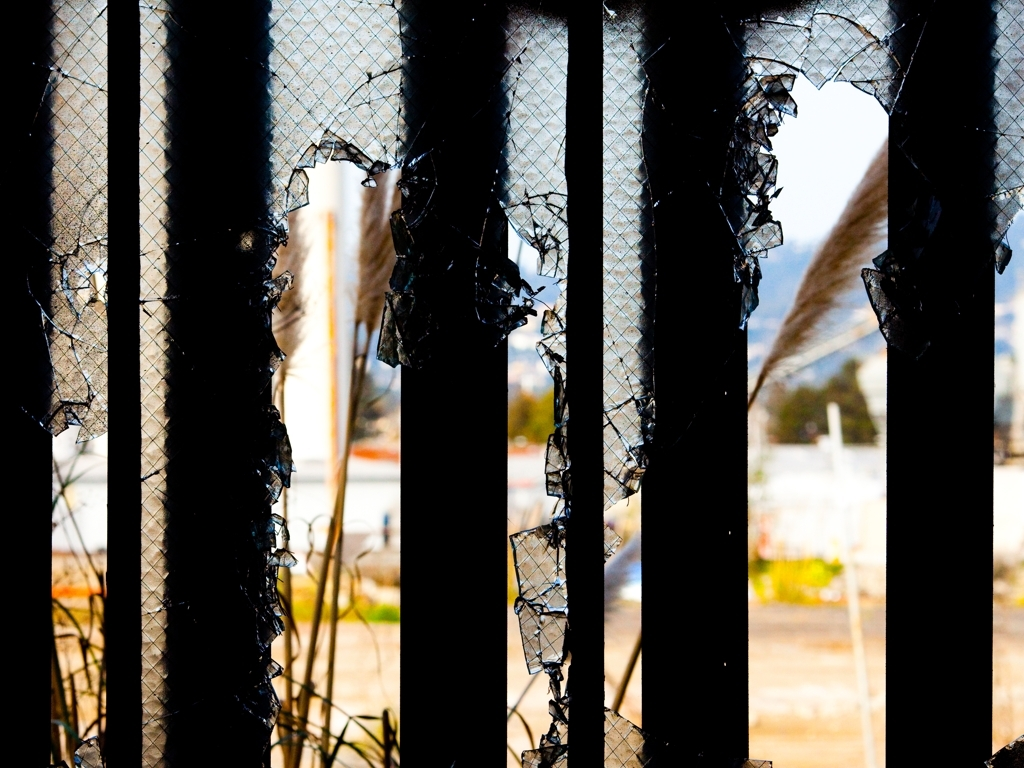Can you tell what the weather might be like in this photo? The lighting in the photo is bright and the shadows are well-defined, suggesting that the sun is shining and that the weather is clear. The absence of any rain or snow on the surfaces further supports the likelihood of fair weather conditions at the time the photo was taken. Thank you. Does the presence of sunlight affect the composition in any way? Yes, the presence of sunlight enhances the contrast between the dark, damaged sections of the barrier and the brighter, untouched areas. It also casts shadows that add depth to the image, emphasizing the texture of the broken material and contributing to the overall visual impact. 